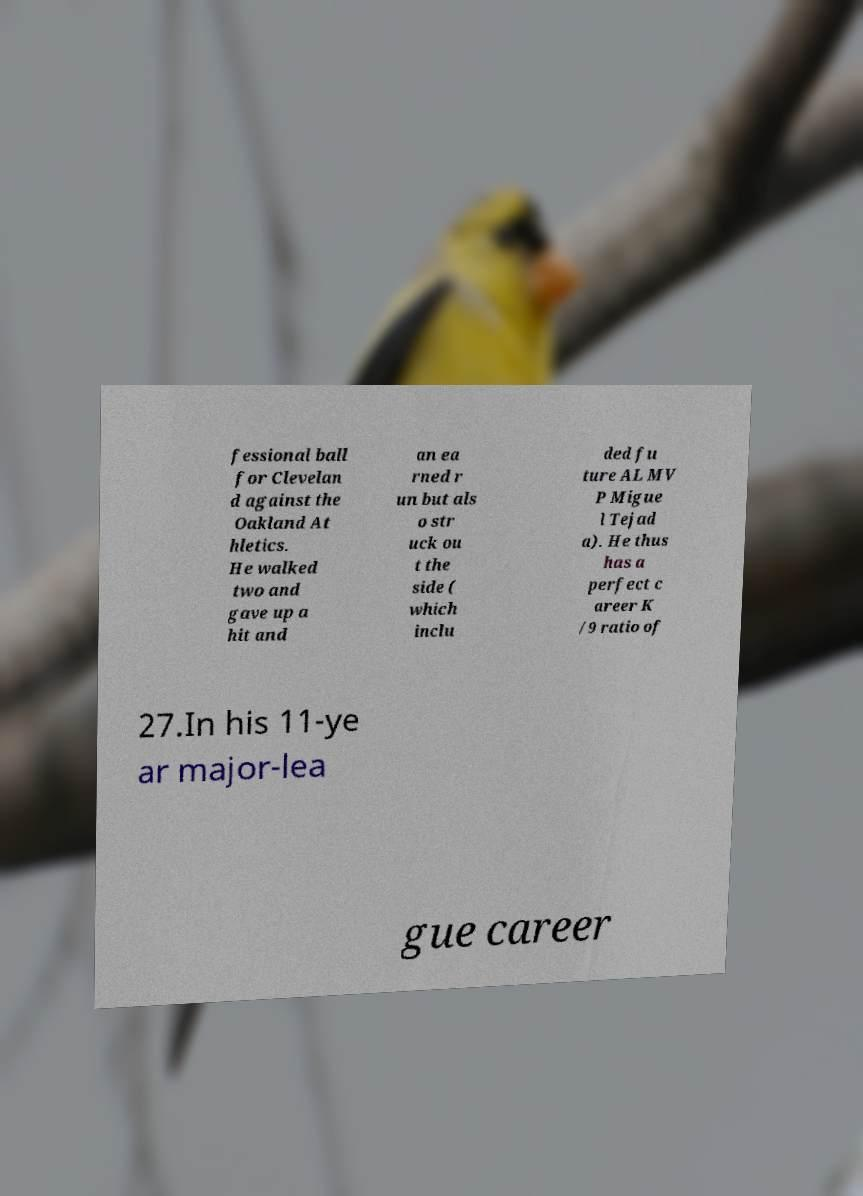Can you accurately transcribe the text from the provided image for me? fessional ball for Clevelan d against the Oakland At hletics. He walked two and gave up a hit and an ea rned r un but als o str uck ou t the side ( which inclu ded fu ture AL MV P Migue l Tejad a). He thus has a perfect c areer K /9 ratio of 27.In his 11-ye ar major-lea gue career 